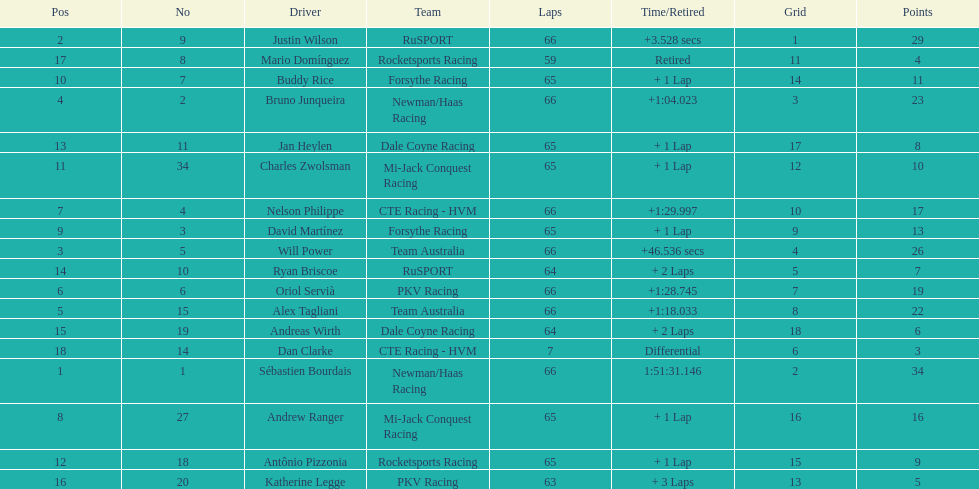At the 2006 gran premio telmex, did oriol servia or katherine legge complete more laps? Oriol Servià. 